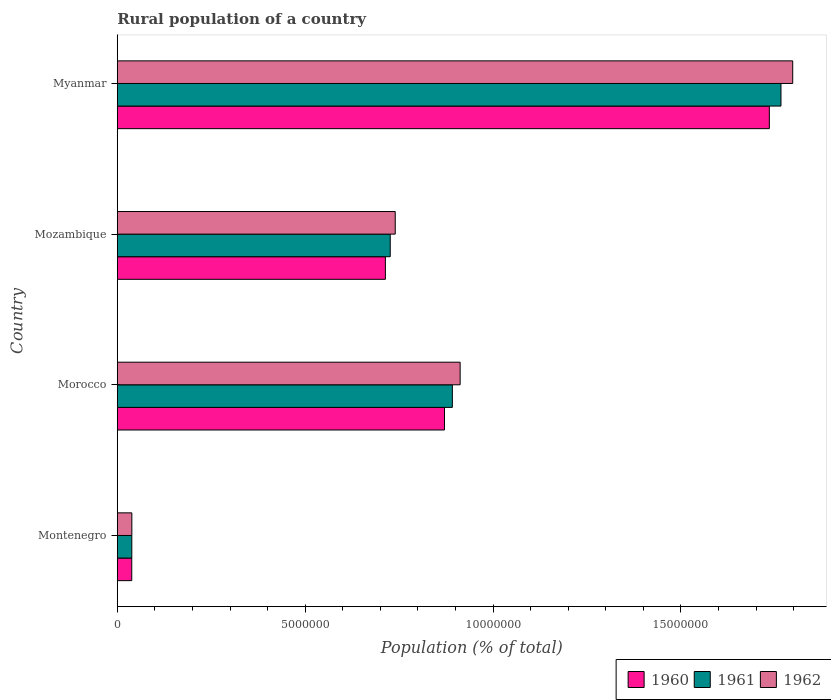Are the number of bars per tick equal to the number of legend labels?
Your response must be concise. Yes. Are the number of bars on each tick of the Y-axis equal?
Your answer should be very brief. Yes. How many bars are there on the 1st tick from the bottom?
Provide a short and direct response. 3. What is the label of the 2nd group of bars from the top?
Your response must be concise. Mozambique. In how many cases, is the number of bars for a given country not equal to the number of legend labels?
Offer a terse response. 0. What is the rural population in 1961 in Montenegro?
Offer a terse response. 3.87e+05. Across all countries, what is the maximum rural population in 1962?
Offer a very short reply. 1.80e+07. Across all countries, what is the minimum rural population in 1961?
Offer a terse response. 3.87e+05. In which country was the rural population in 1960 maximum?
Provide a succinct answer. Myanmar. In which country was the rural population in 1961 minimum?
Your answer should be very brief. Montenegro. What is the total rural population in 1960 in the graph?
Offer a terse response. 3.36e+07. What is the difference between the rural population in 1961 in Montenegro and that in Morocco?
Your response must be concise. -8.53e+06. What is the difference between the rural population in 1961 in Morocco and the rural population in 1960 in Mozambique?
Your answer should be compact. 1.78e+06. What is the average rural population in 1960 per country?
Offer a terse response. 8.40e+06. What is the difference between the rural population in 1961 and rural population in 1962 in Mozambique?
Keep it short and to the point. -1.33e+05. In how many countries, is the rural population in 1960 greater than 6000000 %?
Offer a very short reply. 3. What is the ratio of the rural population in 1962 in Morocco to that in Myanmar?
Provide a short and direct response. 0.51. Is the rural population in 1960 in Montenegro less than that in Mozambique?
Offer a very short reply. Yes. Is the difference between the rural population in 1961 in Montenegro and Mozambique greater than the difference between the rural population in 1962 in Montenegro and Mozambique?
Keep it short and to the point. Yes. What is the difference between the highest and the second highest rural population in 1961?
Provide a short and direct response. 8.75e+06. What is the difference between the highest and the lowest rural population in 1960?
Your answer should be very brief. 1.70e+07. In how many countries, is the rural population in 1961 greater than the average rural population in 1961 taken over all countries?
Provide a succinct answer. 2. Are all the bars in the graph horizontal?
Your answer should be compact. Yes. How many countries are there in the graph?
Give a very brief answer. 4. What is the difference between two consecutive major ticks on the X-axis?
Give a very brief answer. 5.00e+06. Does the graph contain any zero values?
Provide a succinct answer. No. What is the title of the graph?
Give a very brief answer. Rural population of a country. Does "2011" appear as one of the legend labels in the graph?
Offer a terse response. No. What is the label or title of the X-axis?
Give a very brief answer. Population (% of total). What is the Population (% of total) of 1960 in Montenegro?
Make the answer very short. 3.85e+05. What is the Population (% of total) of 1961 in Montenegro?
Your answer should be compact. 3.87e+05. What is the Population (% of total) in 1962 in Montenegro?
Offer a terse response. 3.88e+05. What is the Population (% of total) in 1960 in Morocco?
Provide a short and direct response. 8.71e+06. What is the Population (% of total) in 1961 in Morocco?
Your response must be concise. 8.92e+06. What is the Population (% of total) in 1962 in Morocco?
Keep it short and to the point. 9.13e+06. What is the Population (% of total) in 1960 in Mozambique?
Your response must be concise. 7.14e+06. What is the Population (% of total) of 1961 in Mozambique?
Your response must be concise. 7.27e+06. What is the Population (% of total) in 1962 in Mozambique?
Offer a terse response. 7.40e+06. What is the Population (% of total) of 1960 in Myanmar?
Offer a very short reply. 1.74e+07. What is the Population (% of total) of 1961 in Myanmar?
Provide a short and direct response. 1.77e+07. What is the Population (% of total) in 1962 in Myanmar?
Give a very brief answer. 1.80e+07. Across all countries, what is the maximum Population (% of total) of 1960?
Keep it short and to the point. 1.74e+07. Across all countries, what is the maximum Population (% of total) of 1961?
Give a very brief answer. 1.77e+07. Across all countries, what is the maximum Population (% of total) of 1962?
Offer a very short reply. 1.80e+07. Across all countries, what is the minimum Population (% of total) in 1960?
Make the answer very short. 3.85e+05. Across all countries, what is the minimum Population (% of total) in 1961?
Keep it short and to the point. 3.87e+05. Across all countries, what is the minimum Population (% of total) in 1962?
Your answer should be very brief. 3.88e+05. What is the total Population (% of total) of 1960 in the graph?
Provide a succinct answer. 3.36e+07. What is the total Population (% of total) of 1961 in the graph?
Your answer should be compact. 3.42e+07. What is the total Population (% of total) of 1962 in the graph?
Offer a very short reply. 3.49e+07. What is the difference between the Population (% of total) of 1960 in Montenegro and that in Morocco?
Give a very brief answer. -8.32e+06. What is the difference between the Population (% of total) in 1961 in Montenegro and that in Morocco?
Offer a very short reply. -8.53e+06. What is the difference between the Population (% of total) of 1962 in Montenegro and that in Morocco?
Keep it short and to the point. -8.74e+06. What is the difference between the Population (% of total) in 1960 in Montenegro and that in Mozambique?
Your answer should be very brief. -6.75e+06. What is the difference between the Population (% of total) of 1961 in Montenegro and that in Mozambique?
Give a very brief answer. -6.88e+06. What is the difference between the Population (% of total) in 1962 in Montenegro and that in Mozambique?
Give a very brief answer. -7.01e+06. What is the difference between the Population (% of total) in 1960 in Montenegro and that in Myanmar?
Offer a terse response. -1.70e+07. What is the difference between the Population (% of total) of 1961 in Montenegro and that in Myanmar?
Make the answer very short. -1.73e+07. What is the difference between the Population (% of total) in 1962 in Montenegro and that in Myanmar?
Provide a short and direct response. -1.76e+07. What is the difference between the Population (% of total) in 1960 in Morocco and that in Mozambique?
Your response must be concise. 1.57e+06. What is the difference between the Population (% of total) in 1961 in Morocco and that in Mozambique?
Offer a very short reply. 1.65e+06. What is the difference between the Population (% of total) in 1962 in Morocco and that in Mozambique?
Your answer should be compact. 1.73e+06. What is the difference between the Population (% of total) of 1960 in Morocco and that in Myanmar?
Ensure brevity in your answer.  -8.65e+06. What is the difference between the Population (% of total) in 1961 in Morocco and that in Myanmar?
Offer a terse response. -8.75e+06. What is the difference between the Population (% of total) in 1962 in Morocco and that in Myanmar?
Offer a terse response. -8.85e+06. What is the difference between the Population (% of total) in 1960 in Mozambique and that in Myanmar?
Make the answer very short. -1.02e+07. What is the difference between the Population (% of total) of 1961 in Mozambique and that in Myanmar?
Ensure brevity in your answer.  -1.04e+07. What is the difference between the Population (% of total) in 1962 in Mozambique and that in Myanmar?
Provide a succinct answer. -1.06e+07. What is the difference between the Population (% of total) of 1960 in Montenegro and the Population (% of total) of 1961 in Morocco?
Give a very brief answer. -8.53e+06. What is the difference between the Population (% of total) of 1960 in Montenegro and the Population (% of total) of 1962 in Morocco?
Keep it short and to the point. -8.74e+06. What is the difference between the Population (% of total) of 1961 in Montenegro and the Population (% of total) of 1962 in Morocco?
Offer a terse response. -8.74e+06. What is the difference between the Population (% of total) of 1960 in Montenegro and the Population (% of total) of 1961 in Mozambique?
Make the answer very short. -6.88e+06. What is the difference between the Population (% of total) of 1960 in Montenegro and the Population (% of total) of 1962 in Mozambique?
Offer a very short reply. -7.01e+06. What is the difference between the Population (% of total) in 1961 in Montenegro and the Population (% of total) in 1962 in Mozambique?
Your response must be concise. -7.01e+06. What is the difference between the Population (% of total) in 1960 in Montenegro and the Population (% of total) in 1961 in Myanmar?
Ensure brevity in your answer.  -1.73e+07. What is the difference between the Population (% of total) of 1960 in Montenegro and the Population (% of total) of 1962 in Myanmar?
Your response must be concise. -1.76e+07. What is the difference between the Population (% of total) of 1961 in Montenegro and the Population (% of total) of 1962 in Myanmar?
Keep it short and to the point. -1.76e+07. What is the difference between the Population (% of total) in 1960 in Morocco and the Population (% of total) in 1961 in Mozambique?
Provide a short and direct response. 1.44e+06. What is the difference between the Population (% of total) of 1960 in Morocco and the Population (% of total) of 1962 in Mozambique?
Make the answer very short. 1.31e+06. What is the difference between the Population (% of total) of 1961 in Morocco and the Population (% of total) of 1962 in Mozambique?
Provide a short and direct response. 1.52e+06. What is the difference between the Population (% of total) of 1960 in Morocco and the Population (% of total) of 1961 in Myanmar?
Your answer should be compact. -8.96e+06. What is the difference between the Population (% of total) of 1960 in Morocco and the Population (% of total) of 1962 in Myanmar?
Give a very brief answer. -9.27e+06. What is the difference between the Population (% of total) of 1961 in Morocco and the Population (% of total) of 1962 in Myanmar?
Provide a succinct answer. -9.06e+06. What is the difference between the Population (% of total) in 1960 in Mozambique and the Population (% of total) in 1961 in Myanmar?
Provide a succinct answer. -1.05e+07. What is the difference between the Population (% of total) in 1960 in Mozambique and the Population (% of total) in 1962 in Myanmar?
Your answer should be compact. -1.08e+07. What is the difference between the Population (% of total) in 1961 in Mozambique and the Population (% of total) in 1962 in Myanmar?
Your answer should be compact. -1.07e+07. What is the average Population (% of total) in 1960 per country?
Your response must be concise. 8.40e+06. What is the average Population (% of total) of 1961 per country?
Offer a terse response. 8.56e+06. What is the average Population (% of total) of 1962 per country?
Your answer should be compact. 8.72e+06. What is the difference between the Population (% of total) of 1960 and Population (% of total) of 1961 in Montenegro?
Keep it short and to the point. -1569. What is the difference between the Population (% of total) in 1960 and Population (% of total) in 1962 in Montenegro?
Offer a terse response. -2612. What is the difference between the Population (% of total) of 1961 and Population (% of total) of 1962 in Montenegro?
Keep it short and to the point. -1043. What is the difference between the Population (% of total) in 1960 and Population (% of total) in 1961 in Morocco?
Your response must be concise. -2.09e+05. What is the difference between the Population (% of total) of 1960 and Population (% of total) of 1962 in Morocco?
Keep it short and to the point. -4.16e+05. What is the difference between the Population (% of total) of 1961 and Population (% of total) of 1962 in Morocco?
Make the answer very short. -2.07e+05. What is the difference between the Population (% of total) in 1960 and Population (% of total) in 1961 in Mozambique?
Your answer should be very brief. -1.29e+05. What is the difference between the Population (% of total) of 1960 and Population (% of total) of 1962 in Mozambique?
Ensure brevity in your answer.  -2.62e+05. What is the difference between the Population (% of total) of 1961 and Population (% of total) of 1962 in Mozambique?
Keep it short and to the point. -1.33e+05. What is the difference between the Population (% of total) in 1960 and Population (% of total) in 1961 in Myanmar?
Offer a terse response. -3.09e+05. What is the difference between the Population (% of total) of 1960 and Population (% of total) of 1962 in Myanmar?
Keep it short and to the point. -6.22e+05. What is the difference between the Population (% of total) of 1961 and Population (% of total) of 1962 in Myanmar?
Your answer should be very brief. -3.13e+05. What is the ratio of the Population (% of total) in 1960 in Montenegro to that in Morocco?
Your answer should be compact. 0.04. What is the ratio of the Population (% of total) of 1961 in Montenegro to that in Morocco?
Provide a succinct answer. 0.04. What is the ratio of the Population (% of total) in 1962 in Montenegro to that in Morocco?
Offer a very short reply. 0.04. What is the ratio of the Population (% of total) in 1960 in Montenegro to that in Mozambique?
Ensure brevity in your answer.  0.05. What is the ratio of the Population (% of total) of 1961 in Montenegro to that in Mozambique?
Make the answer very short. 0.05. What is the ratio of the Population (% of total) of 1962 in Montenegro to that in Mozambique?
Give a very brief answer. 0.05. What is the ratio of the Population (% of total) of 1960 in Montenegro to that in Myanmar?
Make the answer very short. 0.02. What is the ratio of the Population (% of total) in 1961 in Montenegro to that in Myanmar?
Your answer should be compact. 0.02. What is the ratio of the Population (% of total) of 1962 in Montenegro to that in Myanmar?
Provide a succinct answer. 0.02. What is the ratio of the Population (% of total) of 1960 in Morocco to that in Mozambique?
Your answer should be very brief. 1.22. What is the ratio of the Population (% of total) of 1961 in Morocco to that in Mozambique?
Ensure brevity in your answer.  1.23. What is the ratio of the Population (% of total) of 1962 in Morocco to that in Mozambique?
Offer a terse response. 1.23. What is the ratio of the Population (% of total) of 1960 in Morocco to that in Myanmar?
Offer a terse response. 0.5. What is the ratio of the Population (% of total) of 1961 in Morocco to that in Myanmar?
Offer a terse response. 0.5. What is the ratio of the Population (% of total) in 1962 in Morocco to that in Myanmar?
Ensure brevity in your answer.  0.51. What is the ratio of the Population (% of total) in 1960 in Mozambique to that in Myanmar?
Make the answer very short. 0.41. What is the ratio of the Population (% of total) of 1961 in Mozambique to that in Myanmar?
Your response must be concise. 0.41. What is the ratio of the Population (% of total) in 1962 in Mozambique to that in Myanmar?
Keep it short and to the point. 0.41. What is the difference between the highest and the second highest Population (% of total) of 1960?
Offer a terse response. 8.65e+06. What is the difference between the highest and the second highest Population (% of total) of 1961?
Your answer should be very brief. 8.75e+06. What is the difference between the highest and the second highest Population (% of total) of 1962?
Your answer should be compact. 8.85e+06. What is the difference between the highest and the lowest Population (% of total) in 1960?
Give a very brief answer. 1.70e+07. What is the difference between the highest and the lowest Population (% of total) in 1961?
Offer a very short reply. 1.73e+07. What is the difference between the highest and the lowest Population (% of total) in 1962?
Your answer should be very brief. 1.76e+07. 